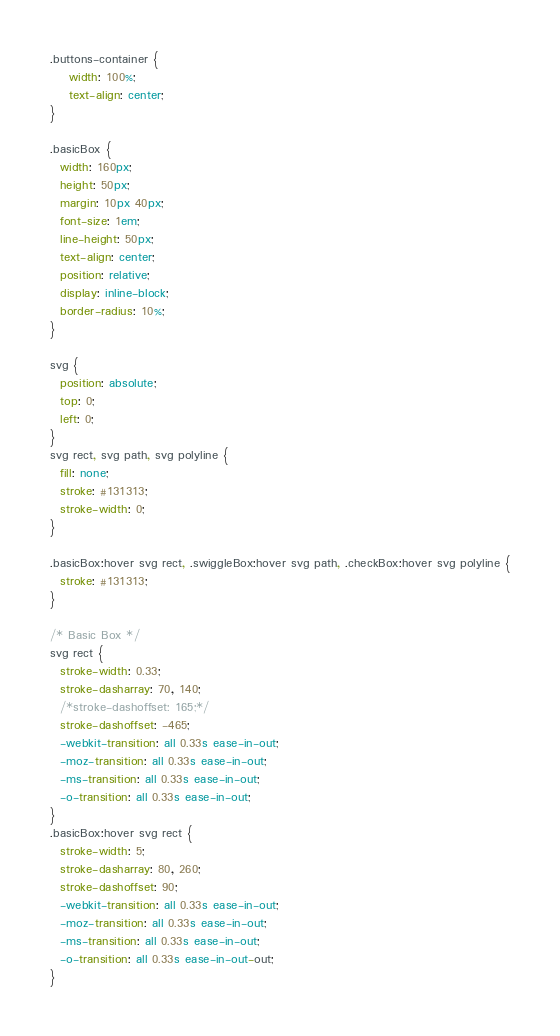Convert code to text. <code><loc_0><loc_0><loc_500><loc_500><_CSS_>.buttons-container {
    width: 100%;
    text-align: center;
}

.basicBox {
  width: 160px;
  height: 50px;
  margin: 10px 40px;
  font-size: 1em;
  line-height: 50px;
  text-align: center;
  position: relative;
  display: inline-block;
  border-radius: 10%;
}

svg {
  position: absolute;
  top: 0;
  left: 0;
}
svg rect, svg path, svg polyline {
  fill: none;
  stroke: #131313;
  stroke-width: 0;
}

.basicBox:hover svg rect, .swiggleBox:hover svg path, .checkBox:hover svg polyline {
  stroke: #131313;
}

/* Basic Box */
svg rect {
  stroke-width: 0.33;
  stroke-dasharray: 70, 140;
  /*stroke-dashoffset: 165;*/
  stroke-dashoffset: -465;
  -webkit-transition: all 0.33s ease-in-out;
  -moz-transition: all 0.33s ease-in-out;
  -ms-transition: all 0.33s ease-in-out;
  -o-transition: all 0.33s ease-in-out;
}
.basicBox:hover svg rect {
  stroke-width: 5;
  stroke-dasharray: 80, 260;
  stroke-dashoffset: 90;
  -webkit-transition: all 0.33s ease-in-out;
  -moz-transition: all 0.33s ease-in-out;
  -ms-transition: all 0.33s ease-in-out;
  -o-transition: all 0.33s ease-in-out-out;
}

</code> 